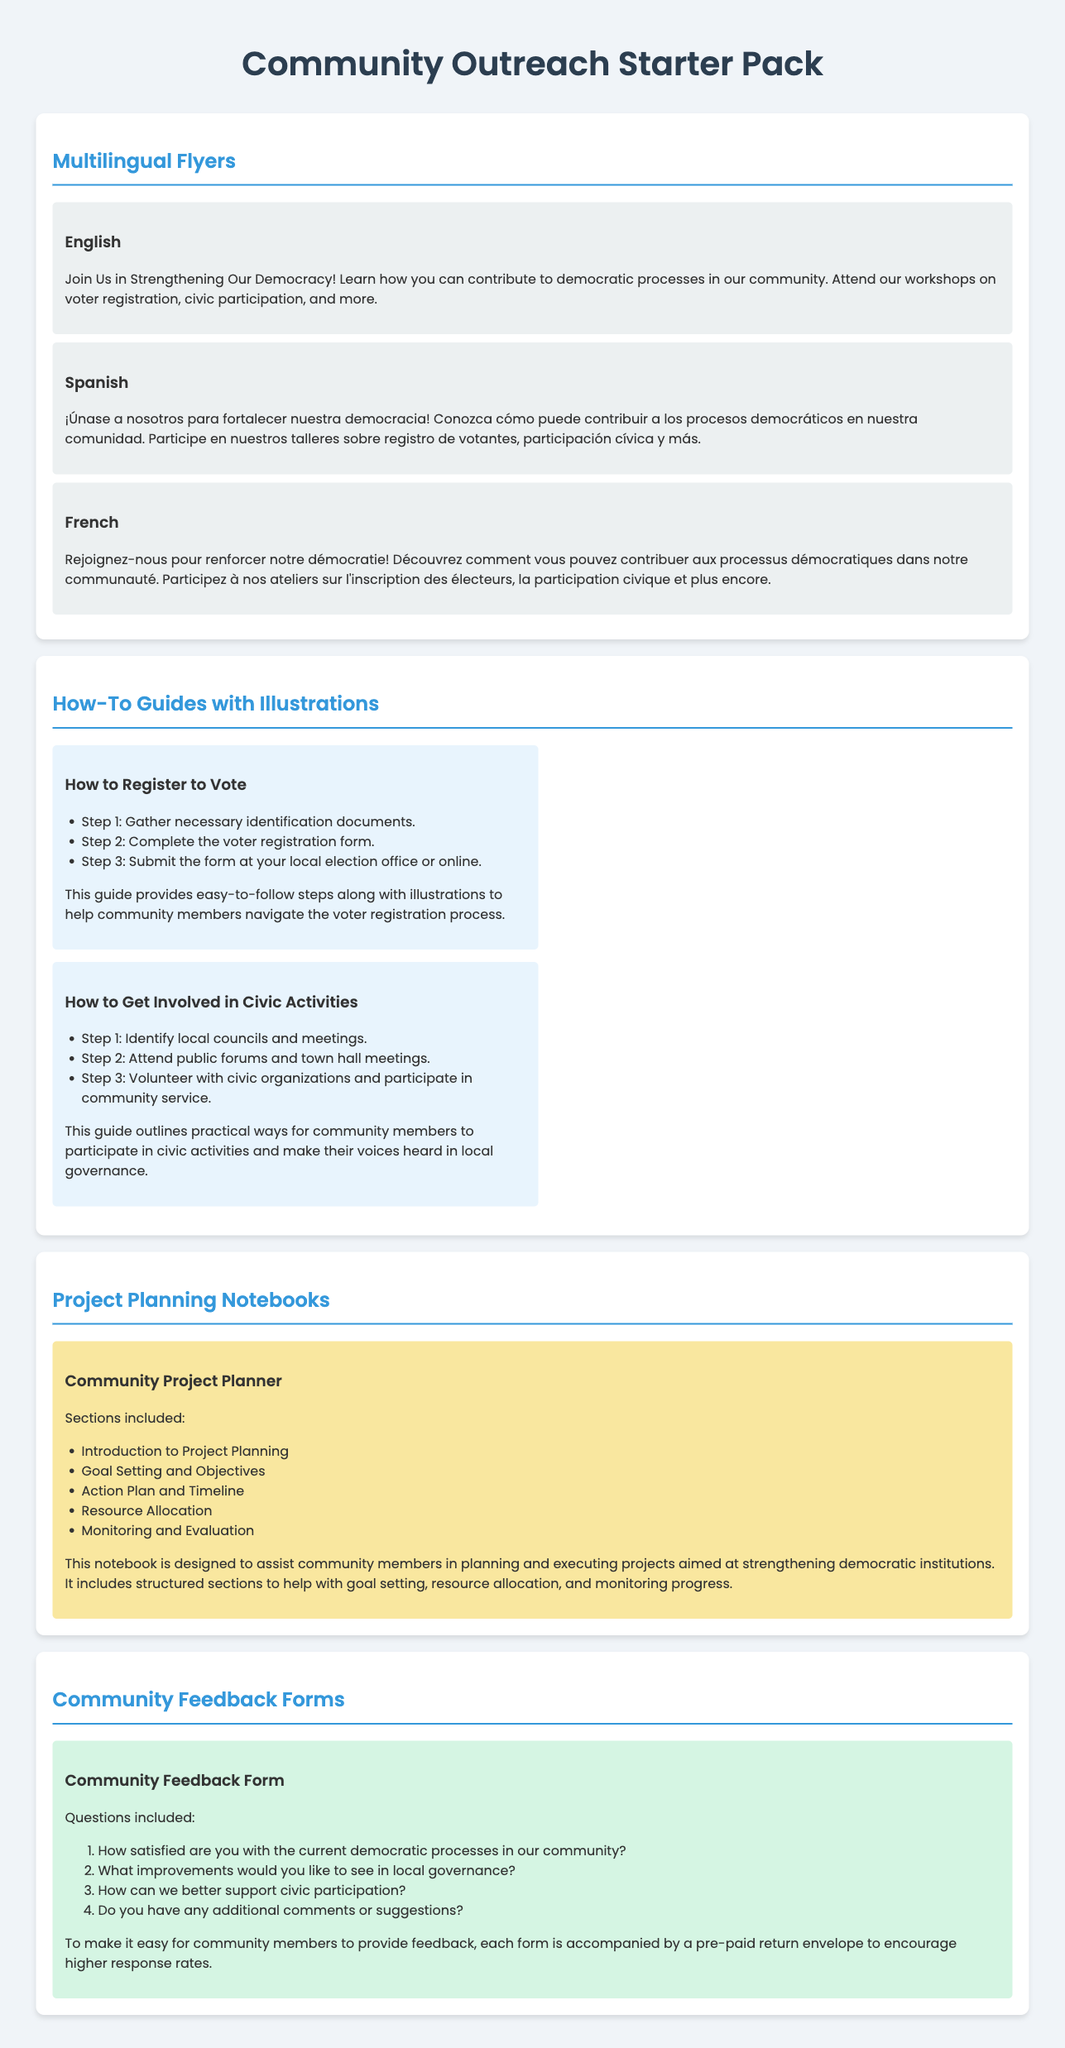what languages are the flyers available in? The document lists multilingual flyers in English, Spanish, and French.
Answer: English, Spanish, French how many how-to guides are provided in the pack? There are two how-to guides included in the document.
Answer: Two what is one topic covered in the community project planner? The community project planner includes various sections; one of them is Goal Setting and Objectives.
Answer: Goal Setting and Objectives what type of feedback does the community feedback form solicit? The feedback form asks for community satisfaction with current democratic processes among other things.
Answer: Satisfaction with current democratic processes what can community members do to provide feedback? Community members can send their feedback through a community feedback form that includes a pre-paid return envelope.
Answer: Use the pre-paid return envelope how many steps are there in the guide on how to register to vote? The guide outlines three steps for registering to vote.
Answer: Three steps what is the purpose of the community feedback forms? The community feedback forms are designed to collect feedback from community members about democratic processes and governance.
Answer: Collect feedback what illustration accompanies the how-to guides? The how-to guides come with illustrations to aid in understanding the provided steps.
Answer: Illustrations which section includes resources for project planning? The Project Planning Notebooks section includes resources for project planning.
Answer: Project Planning Notebooks 